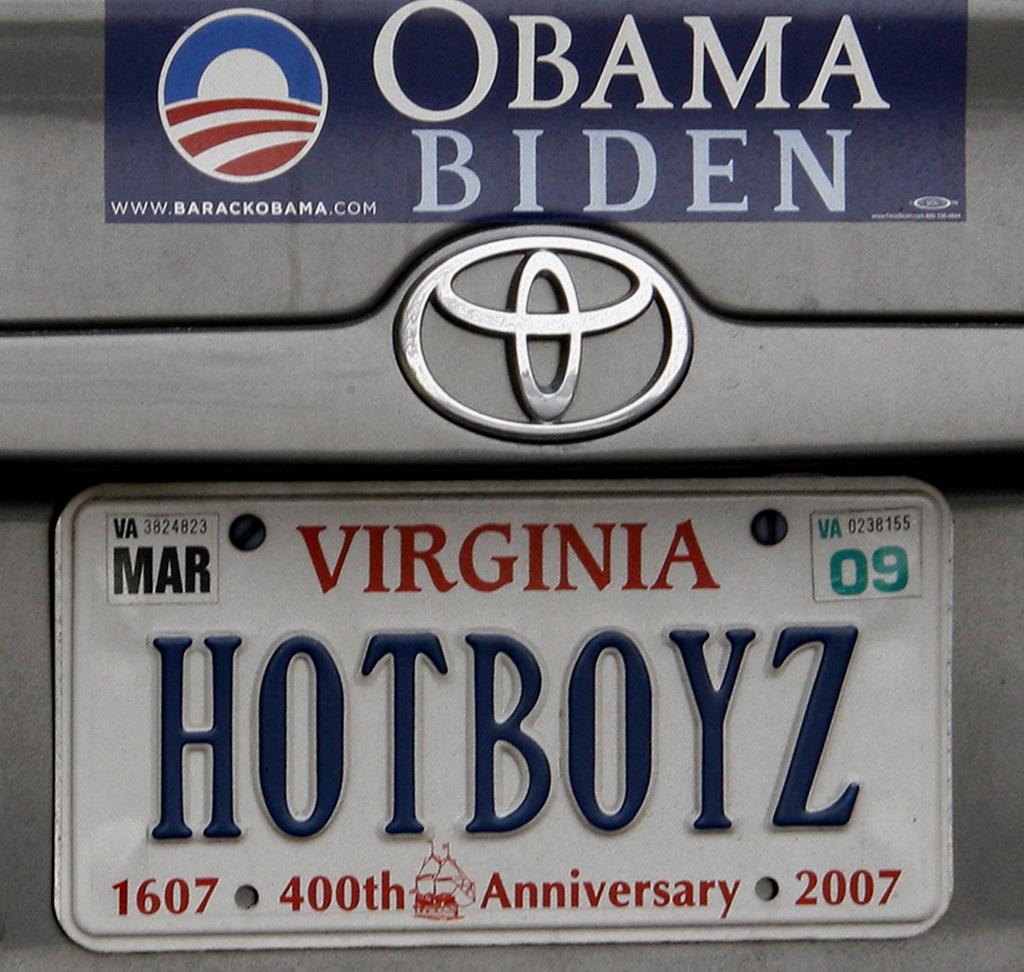What year is on the plate?
Your answer should be very brief. 2007. 